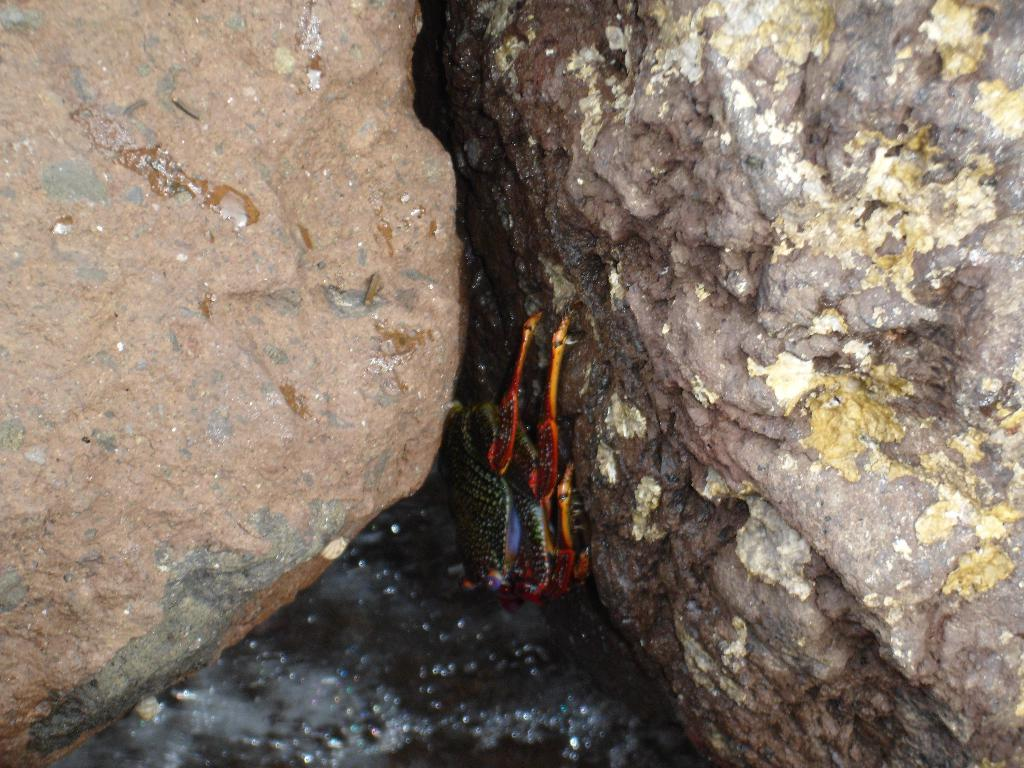How many frogs are present in the image? There are two frogs in the image. Where are the frogs located in relation to the rocks? The frogs are between two rocks. What type of juice can be seen coming out of the faucet in the image? There is no faucet or juice present in the image; it features two frogs between two rocks. 